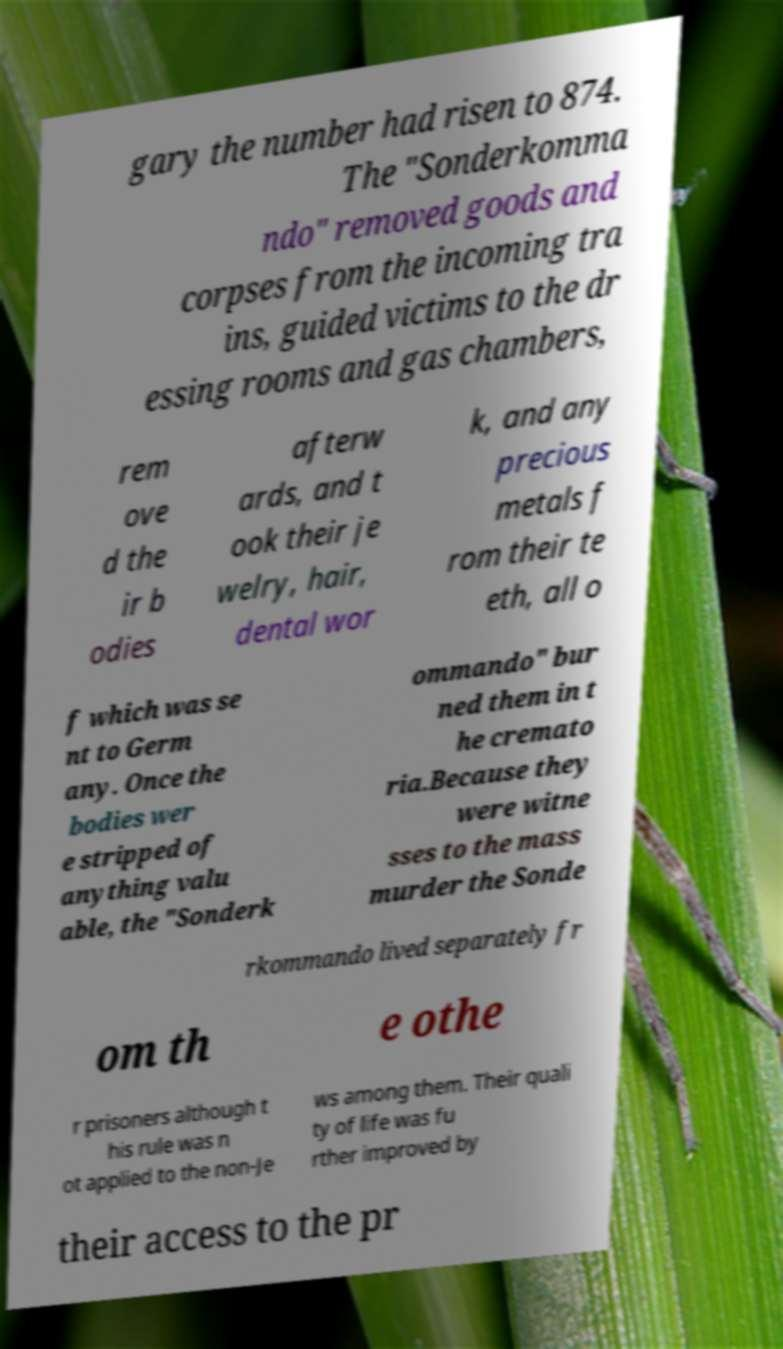I need the written content from this picture converted into text. Can you do that? gary the number had risen to 874. The "Sonderkomma ndo" removed goods and corpses from the incoming tra ins, guided victims to the dr essing rooms and gas chambers, rem ove d the ir b odies afterw ards, and t ook their je welry, hair, dental wor k, and any precious metals f rom their te eth, all o f which was se nt to Germ any. Once the bodies wer e stripped of anything valu able, the "Sonderk ommando" bur ned them in t he cremato ria.Because they were witne sses to the mass murder the Sonde rkommando lived separately fr om th e othe r prisoners although t his rule was n ot applied to the non-Je ws among them. Their quali ty of life was fu rther improved by their access to the pr 